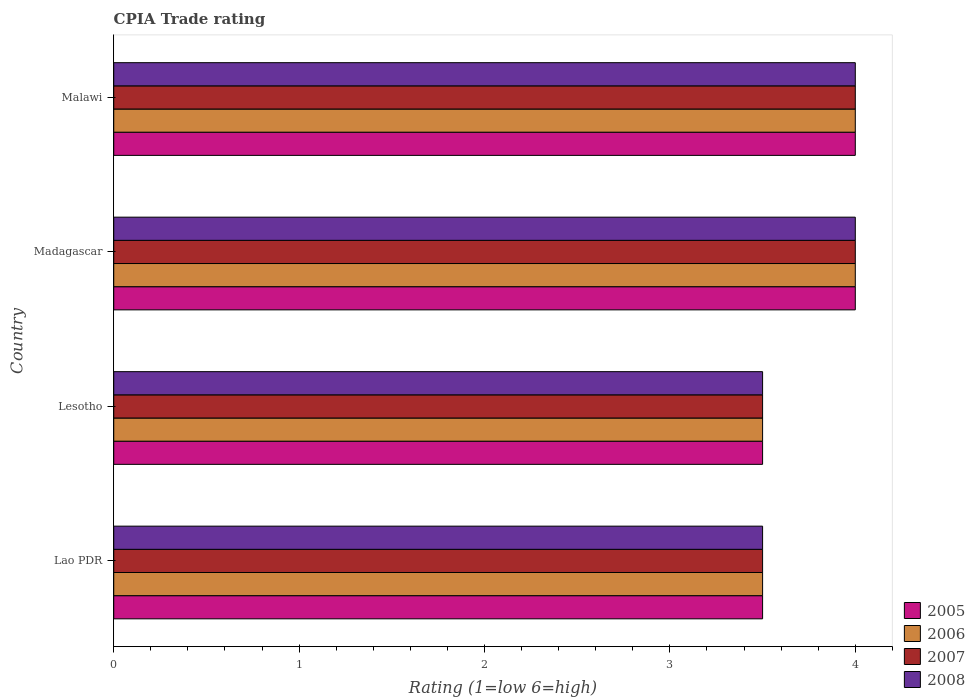How many different coloured bars are there?
Keep it short and to the point. 4. Are the number of bars on each tick of the Y-axis equal?
Provide a short and direct response. Yes. How many bars are there on the 3rd tick from the top?
Give a very brief answer. 4. What is the label of the 4th group of bars from the top?
Offer a terse response. Lao PDR. In how many cases, is the number of bars for a given country not equal to the number of legend labels?
Give a very brief answer. 0. What is the CPIA rating in 2007 in Madagascar?
Provide a short and direct response. 4. Across all countries, what is the maximum CPIA rating in 2007?
Give a very brief answer. 4. In which country was the CPIA rating in 2007 maximum?
Ensure brevity in your answer.  Madagascar. In which country was the CPIA rating in 2008 minimum?
Offer a very short reply. Lao PDR. What is the difference between the CPIA rating in 2006 in Lao PDR and that in Lesotho?
Give a very brief answer. 0. What is the difference between the CPIA rating in 2007 in Lesotho and the CPIA rating in 2008 in Madagascar?
Make the answer very short. -0.5. What is the average CPIA rating in 2006 per country?
Provide a short and direct response. 3.75. In how many countries, is the CPIA rating in 2006 greater than 0.2 ?
Offer a terse response. 4. What is the ratio of the CPIA rating in 2005 in Lao PDR to that in Madagascar?
Keep it short and to the point. 0.88. Is the difference between the CPIA rating in 2008 in Madagascar and Malawi greater than the difference between the CPIA rating in 2005 in Madagascar and Malawi?
Keep it short and to the point. No. What is the difference between the highest and the lowest CPIA rating in 2007?
Your answer should be compact. 0.5. In how many countries, is the CPIA rating in 2006 greater than the average CPIA rating in 2006 taken over all countries?
Your answer should be very brief. 2. Is it the case that in every country, the sum of the CPIA rating in 2007 and CPIA rating in 2006 is greater than the sum of CPIA rating in 2005 and CPIA rating in 2008?
Ensure brevity in your answer.  No. What does the 2nd bar from the top in Malawi represents?
Your answer should be very brief. 2007. Are all the bars in the graph horizontal?
Ensure brevity in your answer.  Yes. How many countries are there in the graph?
Offer a terse response. 4. What is the difference between two consecutive major ticks on the X-axis?
Provide a short and direct response. 1. Does the graph contain any zero values?
Your response must be concise. No. Does the graph contain grids?
Ensure brevity in your answer.  No. How are the legend labels stacked?
Provide a succinct answer. Vertical. What is the title of the graph?
Your answer should be very brief. CPIA Trade rating. What is the label or title of the X-axis?
Keep it short and to the point. Rating (1=low 6=high). What is the Rating (1=low 6=high) of 2006 in Lao PDR?
Provide a short and direct response. 3.5. What is the Rating (1=low 6=high) of 2007 in Lao PDR?
Your answer should be very brief. 3.5. What is the Rating (1=low 6=high) of 2008 in Lao PDR?
Make the answer very short. 3.5. What is the Rating (1=low 6=high) in 2006 in Lesotho?
Your answer should be compact. 3.5. What is the Rating (1=low 6=high) of 2007 in Lesotho?
Provide a short and direct response. 3.5. What is the Rating (1=low 6=high) of 2005 in Madagascar?
Your answer should be very brief. 4. What is the Rating (1=low 6=high) of 2006 in Madagascar?
Offer a terse response. 4. What is the Rating (1=low 6=high) of 2007 in Madagascar?
Provide a succinct answer. 4. What is the Rating (1=low 6=high) in 2005 in Malawi?
Provide a short and direct response. 4. What is the Rating (1=low 6=high) in 2006 in Malawi?
Provide a succinct answer. 4. What is the Rating (1=low 6=high) in 2007 in Malawi?
Your answer should be very brief. 4. What is the Rating (1=low 6=high) of 2008 in Malawi?
Offer a very short reply. 4. Across all countries, what is the maximum Rating (1=low 6=high) in 2005?
Your answer should be very brief. 4. Across all countries, what is the maximum Rating (1=low 6=high) in 2006?
Give a very brief answer. 4. Across all countries, what is the maximum Rating (1=low 6=high) in 2007?
Your answer should be compact. 4. Across all countries, what is the minimum Rating (1=low 6=high) of 2005?
Keep it short and to the point. 3.5. What is the difference between the Rating (1=low 6=high) in 2005 in Lao PDR and that in Lesotho?
Provide a short and direct response. 0. What is the difference between the Rating (1=low 6=high) of 2008 in Lao PDR and that in Lesotho?
Provide a short and direct response. 0. What is the difference between the Rating (1=low 6=high) in 2005 in Lao PDR and that in Madagascar?
Your answer should be very brief. -0.5. What is the difference between the Rating (1=low 6=high) in 2005 in Lao PDR and that in Malawi?
Your answer should be very brief. -0.5. What is the difference between the Rating (1=low 6=high) of 2007 in Lao PDR and that in Malawi?
Your answer should be compact. -0.5. What is the difference between the Rating (1=low 6=high) of 2005 in Lesotho and that in Madagascar?
Make the answer very short. -0.5. What is the difference between the Rating (1=low 6=high) of 2007 in Madagascar and that in Malawi?
Give a very brief answer. 0. What is the difference between the Rating (1=low 6=high) of 2008 in Madagascar and that in Malawi?
Give a very brief answer. 0. What is the difference between the Rating (1=low 6=high) of 2005 in Lao PDR and the Rating (1=low 6=high) of 2006 in Lesotho?
Offer a terse response. 0. What is the difference between the Rating (1=low 6=high) of 2005 in Lao PDR and the Rating (1=low 6=high) of 2007 in Lesotho?
Provide a short and direct response. 0. What is the difference between the Rating (1=low 6=high) in 2006 in Lao PDR and the Rating (1=low 6=high) in 2007 in Lesotho?
Keep it short and to the point. 0. What is the difference between the Rating (1=low 6=high) of 2005 in Lao PDR and the Rating (1=low 6=high) of 2006 in Madagascar?
Your answer should be very brief. -0.5. What is the difference between the Rating (1=low 6=high) in 2005 in Lao PDR and the Rating (1=low 6=high) in 2008 in Madagascar?
Your answer should be very brief. -0.5. What is the difference between the Rating (1=low 6=high) in 2005 in Lao PDR and the Rating (1=low 6=high) in 2006 in Malawi?
Provide a short and direct response. -0.5. What is the difference between the Rating (1=low 6=high) in 2006 in Lao PDR and the Rating (1=low 6=high) in 2007 in Malawi?
Your response must be concise. -0.5. What is the difference between the Rating (1=low 6=high) in 2007 in Lao PDR and the Rating (1=low 6=high) in 2008 in Malawi?
Your answer should be very brief. -0.5. What is the difference between the Rating (1=low 6=high) of 2005 in Lesotho and the Rating (1=low 6=high) of 2008 in Madagascar?
Offer a terse response. -0.5. What is the difference between the Rating (1=low 6=high) in 2006 in Lesotho and the Rating (1=low 6=high) in 2007 in Madagascar?
Your answer should be compact. -0.5. What is the difference between the Rating (1=low 6=high) of 2005 in Lesotho and the Rating (1=low 6=high) of 2006 in Malawi?
Your response must be concise. -0.5. What is the difference between the Rating (1=low 6=high) of 2005 in Lesotho and the Rating (1=low 6=high) of 2007 in Malawi?
Your answer should be compact. -0.5. What is the difference between the Rating (1=low 6=high) of 2005 in Lesotho and the Rating (1=low 6=high) of 2008 in Malawi?
Give a very brief answer. -0.5. What is the difference between the Rating (1=low 6=high) in 2007 in Lesotho and the Rating (1=low 6=high) in 2008 in Malawi?
Make the answer very short. -0.5. What is the difference between the Rating (1=low 6=high) of 2005 in Madagascar and the Rating (1=low 6=high) of 2006 in Malawi?
Give a very brief answer. 0. What is the difference between the Rating (1=low 6=high) of 2006 in Madagascar and the Rating (1=low 6=high) of 2007 in Malawi?
Your answer should be very brief. 0. What is the difference between the Rating (1=low 6=high) of 2006 in Madagascar and the Rating (1=low 6=high) of 2008 in Malawi?
Your answer should be very brief. 0. What is the difference between the Rating (1=low 6=high) in 2007 in Madagascar and the Rating (1=low 6=high) in 2008 in Malawi?
Offer a terse response. 0. What is the average Rating (1=low 6=high) of 2005 per country?
Give a very brief answer. 3.75. What is the average Rating (1=low 6=high) in 2006 per country?
Give a very brief answer. 3.75. What is the average Rating (1=low 6=high) of 2007 per country?
Provide a short and direct response. 3.75. What is the average Rating (1=low 6=high) in 2008 per country?
Your answer should be very brief. 3.75. What is the difference between the Rating (1=low 6=high) of 2005 and Rating (1=low 6=high) of 2006 in Lesotho?
Ensure brevity in your answer.  0. What is the difference between the Rating (1=low 6=high) in 2005 and Rating (1=low 6=high) in 2008 in Lesotho?
Provide a short and direct response. 0. What is the difference between the Rating (1=low 6=high) of 2006 and Rating (1=low 6=high) of 2008 in Lesotho?
Offer a very short reply. 0. What is the difference between the Rating (1=low 6=high) of 2005 and Rating (1=low 6=high) of 2007 in Madagascar?
Make the answer very short. 0. What is the difference between the Rating (1=low 6=high) of 2005 and Rating (1=low 6=high) of 2006 in Malawi?
Your response must be concise. 0. What is the difference between the Rating (1=low 6=high) in 2005 and Rating (1=low 6=high) in 2007 in Malawi?
Your response must be concise. 0. What is the difference between the Rating (1=low 6=high) of 2005 and Rating (1=low 6=high) of 2008 in Malawi?
Your answer should be compact. 0. What is the difference between the Rating (1=low 6=high) of 2007 and Rating (1=low 6=high) of 2008 in Malawi?
Your response must be concise. 0. What is the ratio of the Rating (1=low 6=high) of 2006 in Lao PDR to that in Lesotho?
Provide a succinct answer. 1. What is the ratio of the Rating (1=low 6=high) in 2006 in Lao PDR to that in Madagascar?
Offer a terse response. 0.88. What is the ratio of the Rating (1=low 6=high) of 2007 in Lao PDR to that in Madagascar?
Ensure brevity in your answer.  0.88. What is the ratio of the Rating (1=low 6=high) in 2008 in Lao PDR to that in Madagascar?
Your response must be concise. 0.88. What is the ratio of the Rating (1=low 6=high) in 2005 in Lao PDR to that in Malawi?
Give a very brief answer. 0.88. What is the ratio of the Rating (1=low 6=high) in 2006 in Lao PDR to that in Malawi?
Offer a terse response. 0.88. What is the ratio of the Rating (1=low 6=high) in 2007 in Lao PDR to that in Malawi?
Your answer should be compact. 0.88. What is the ratio of the Rating (1=low 6=high) of 2005 in Lesotho to that in Madagascar?
Give a very brief answer. 0.88. What is the ratio of the Rating (1=low 6=high) of 2006 in Lesotho to that in Madagascar?
Provide a succinct answer. 0.88. What is the ratio of the Rating (1=low 6=high) in 2007 in Lesotho to that in Madagascar?
Your answer should be compact. 0.88. What is the ratio of the Rating (1=low 6=high) in 2008 in Lesotho to that in Madagascar?
Keep it short and to the point. 0.88. What is the ratio of the Rating (1=low 6=high) of 2006 in Lesotho to that in Malawi?
Keep it short and to the point. 0.88. What is the ratio of the Rating (1=low 6=high) in 2007 in Lesotho to that in Malawi?
Your answer should be compact. 0.88. What is the ratio of the Rating (1=low 6=high) of 2005 in Madagascar to that in Malawi?
Your answer should be very brief. 1. What is the ratio of the Rating (1=low 6=high) in 2007 in Madagascar to that in Malawi?
Offer a very short reply. 1. What is the difference between the highest and the second highest Rating (1=low 6=high) in 2006?
Keep it short and to the point. 0. What is the difference between the highest and the second highest Rating (1=low 6=high) of 2008?
Offer a terse response. 0. What is the difference between the highest and the lowest Rating (1=low 6=high) of 2007?
Your response must be concise. 0.5. 